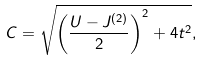Convert formula to latex. <formula><loc_0><loc_0><loc_500><loc_500>C = \sqrt { { \left ( \frac { U - J ^ { ( 2 ) } } 2 \right ) } ^ { 2 } + 4 t ^ { 2 } } ,</formula> 